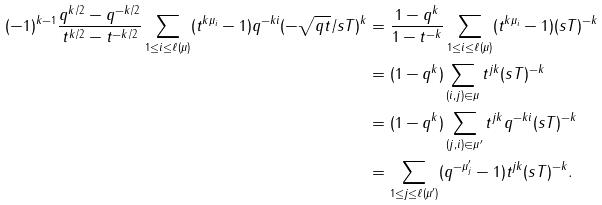<formula> <loc_0><loc_0><loc_500><loc_500>( - 1 ) ^ { k - 1 } \frac { q ^ { k / 2 } - q ^ { - k / 2 } } { t ^ { k / 2 } - t ^ { - k / 2 } } \sum _ { 1 \leq i \leq \ell ( \mu ) } ( t ^ { k \mu _ { i } } - 1 ) q ^ { - k i } ( - \sqrt { q t } / s T ) ^ { k } & = \frac { 1 - q ^ { k } } { 1 - t ^ { - k } } \sum _ { 1 \leq i \leq \ell ( \mu ) } ( t ^ { k \mu _ { i } } - 1 ) ( s T ) ^ { - k } \\ & = ( 1 - q ^ { k } ) \sum _ { ( i , j ) \in \mu } t ^ { j k } ( s T ) ^ { - k } \\ & = ( 1 - q ^ { k } ) \sum _ { ( j , i ) \in \mu ^ { \prime } } t ^ { j k } q ^ { - k i } ( s T ) ^ { - k } \\ & = \sum _ { 1 \leq j \leq \ell ( \mu ^ { \prime } ) } ( q ^ { - \mu ^ { \prime } _ { j } } - 1 ) t ^ { j k } ( s T ) ^ { - k } .</formula> 